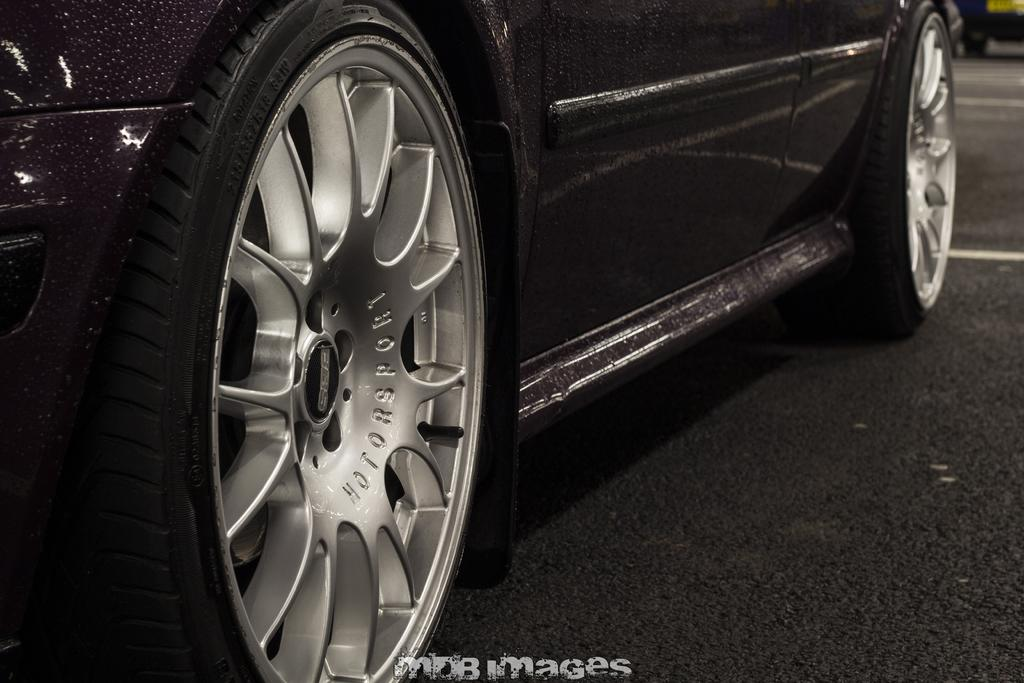What is the main subject of the image? There is a vehicle on the road in the image. Can you describe the background of the image? The background of the image is blurry. Is there any text present in the image? Yes, there is text visible at the bottom of the image. How many goldfish are swimming in the vehicle's engine in the image? There are no goldfish present in the image, and therefore no such activity can be observed. 